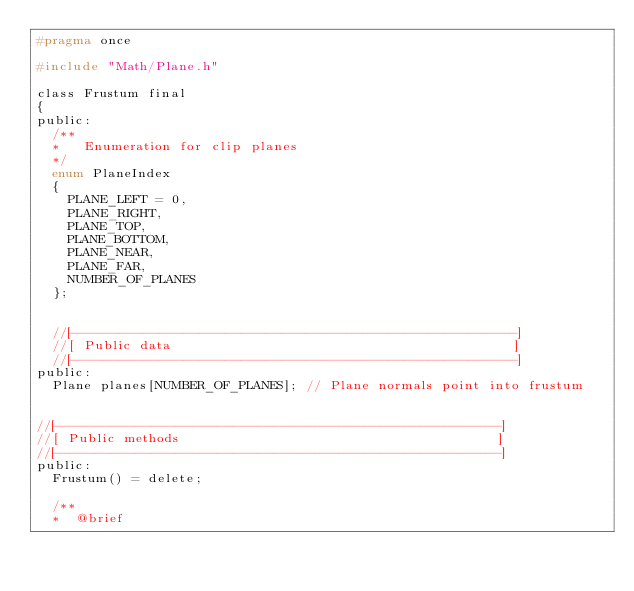<code> <loc_0><loc_0><loc_500><loc_500><_C_>#pragma once

#include "Math/Plane.h"

class Frustum final
{
public:
	/**
	*   Enumeration for clip planes
	*/
	enum PlaneIndex
	{
		PLANE_LEFT = 0,
		PLANE_RIGHT,
		PLANE_TOP,
		PLANE_BOTTOM,
		PLANE_NEAR,
		PLANE_FAR,
		NUMBER_OF_PLANES
	};


	//[-------------------------------------------------------]
	//[ Public data                                           ]
	//[-------------------------------------------------------]
public:
	Plane planes[NUMBER_OF_PLANES];	// Plane normals point into frustum


//[-------------------------------------------------------]
//[ Public methods                                        ]
//[-------------------------------------------------------]
public:
	Frustum() = delete;

	/**
	*  @brief</code> 